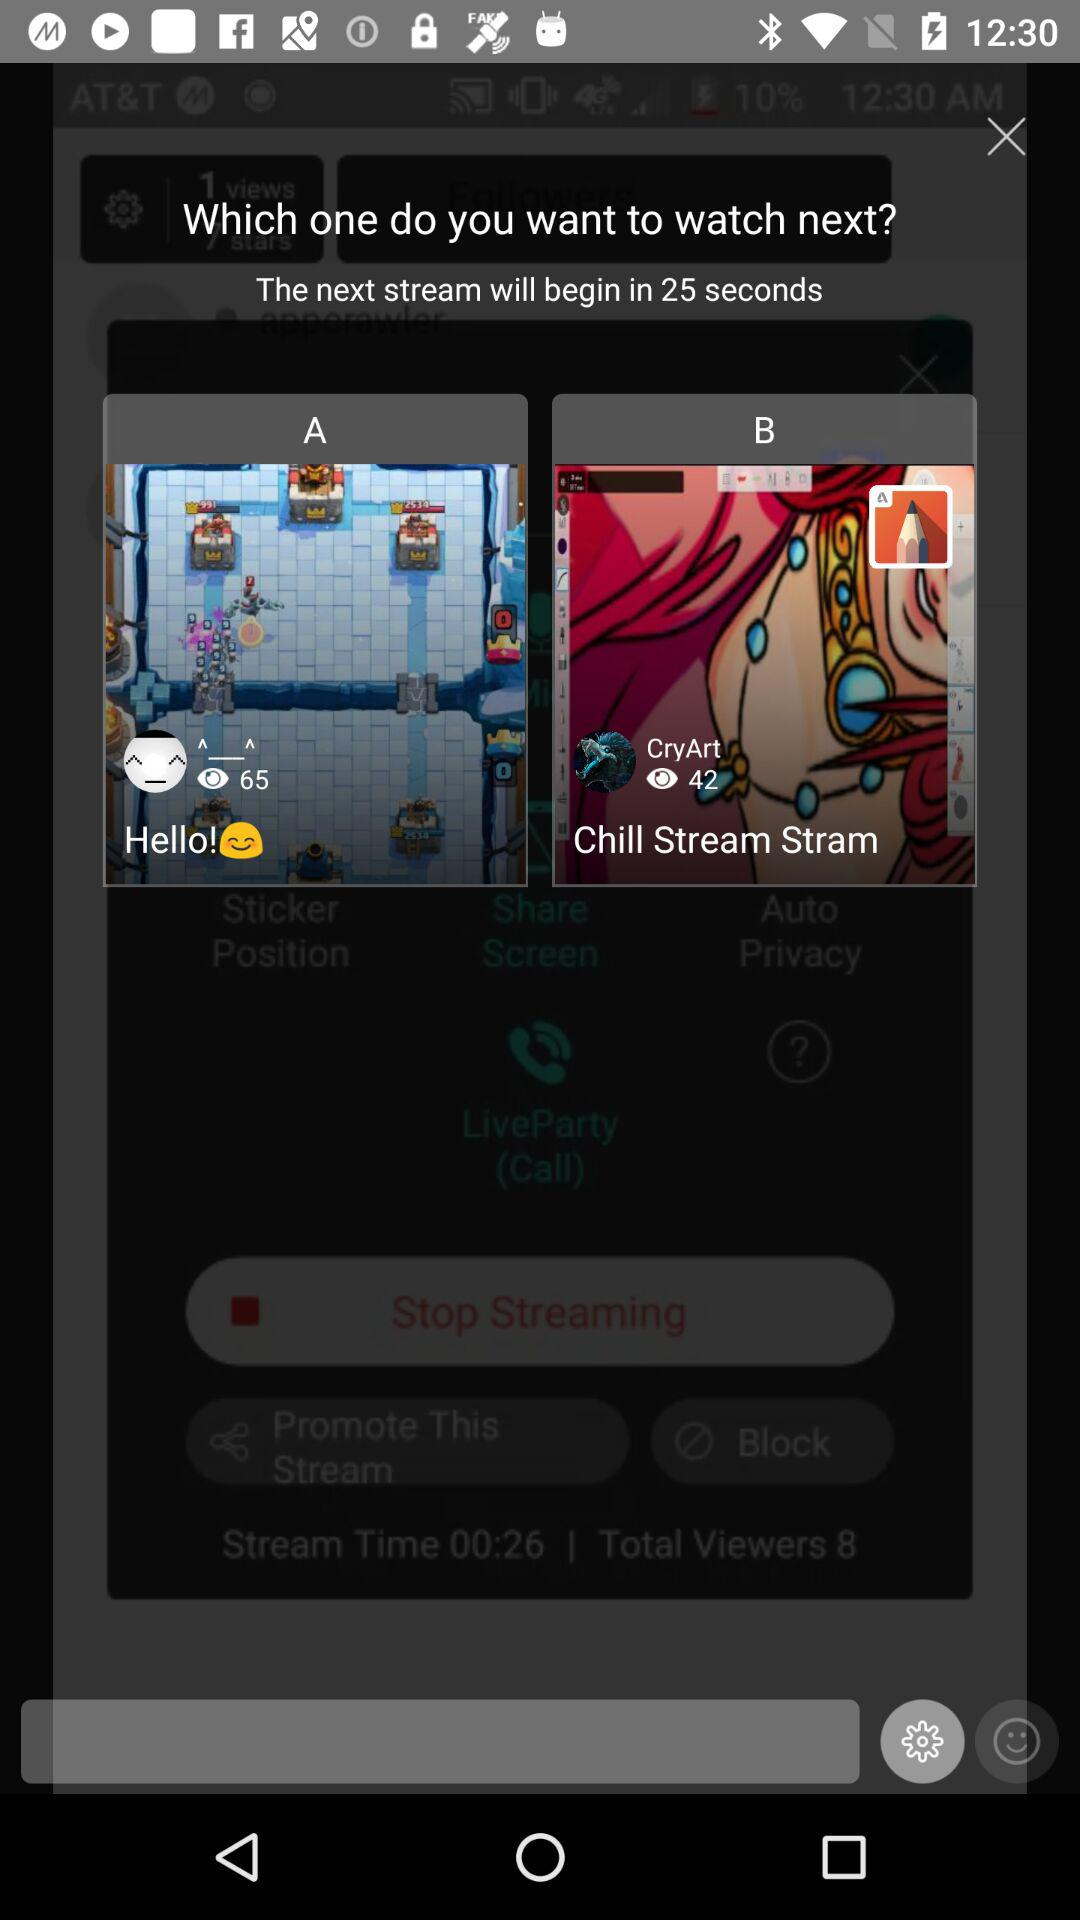In how many seconds will the next stream begin? The next stream will begin in 25 seconds. 